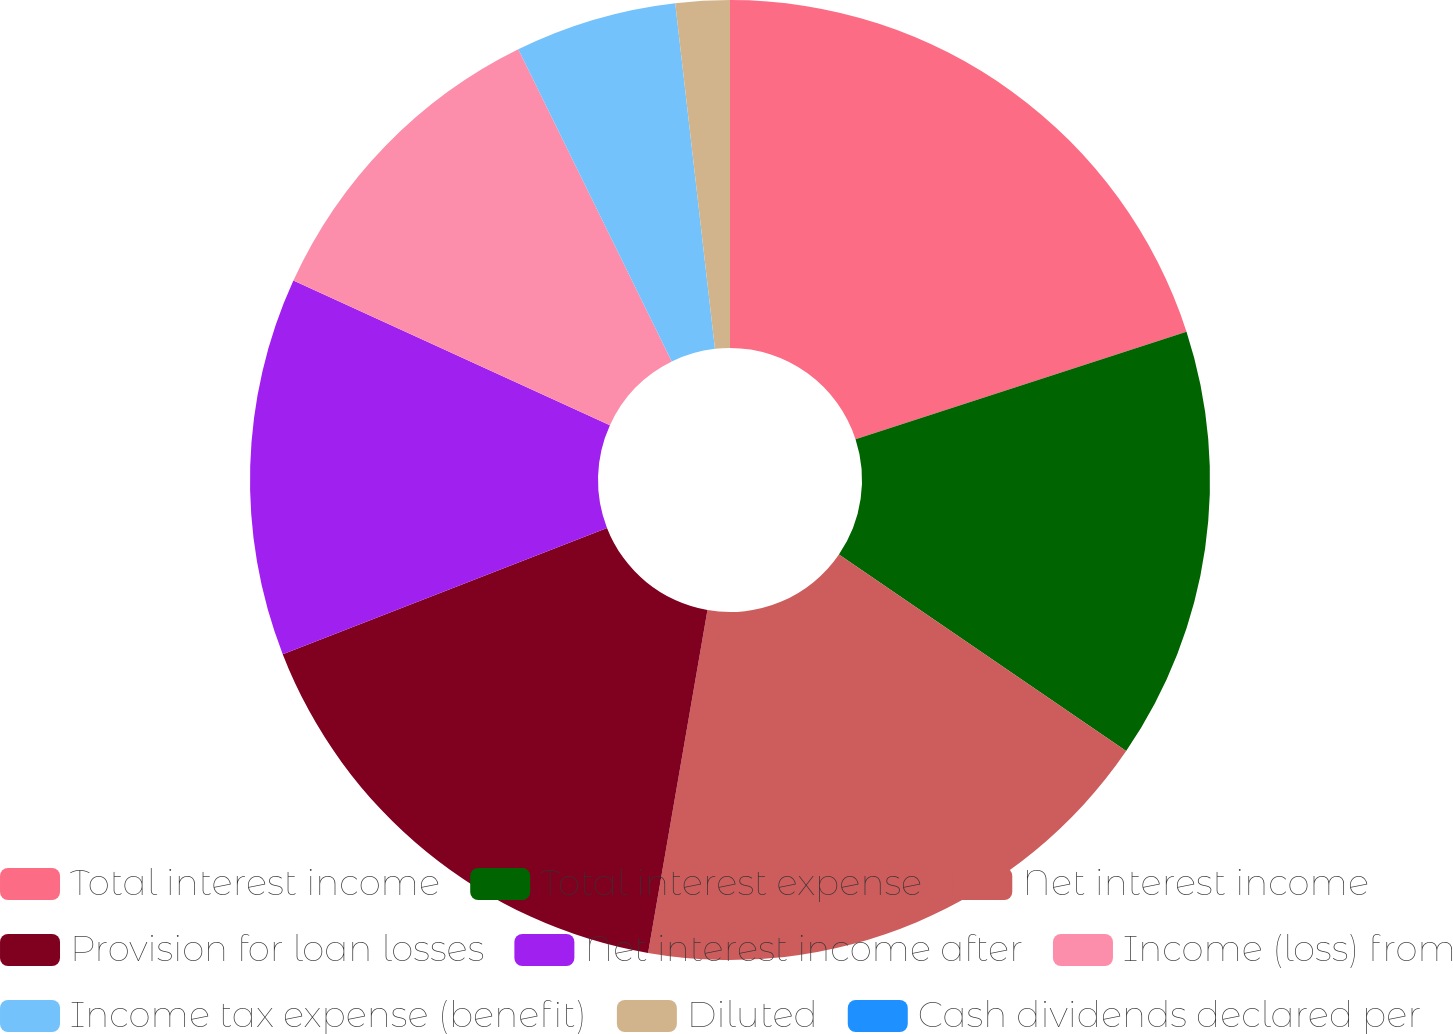<chart> <loc_0><loc_0><loc_500><loc_500><pie_chart><fcel>Total interest income<fcel>Total interest expense<fcel>Net interest income<fcel>Provision for loan losses<fcel>Net interest income after<fcel>Income (loss) from<fcel>Income tax expense (benefit)<fcel>Diluted<fcel>Cash dividends declared per<nl><fcel>20.0%<fcel>14.55%<fcel>18.18%<fcel>16.36%<fcel>12.73%<fcel>10.91%<fcel>5.45%<fcel>1.82%<fcel>0.0%<nl></chart> 